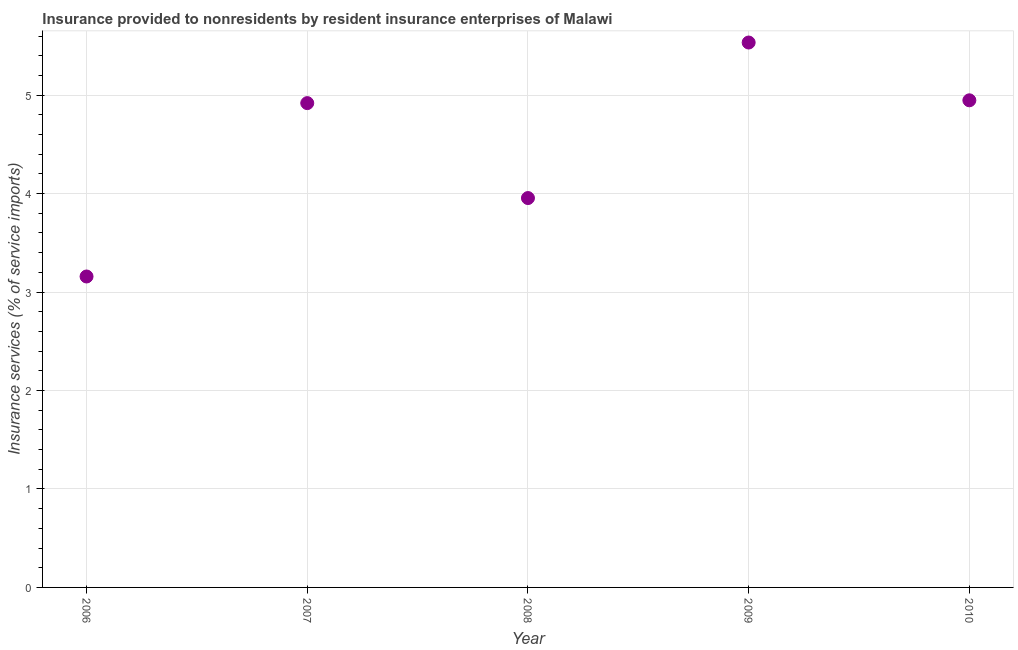What is the insurance and financial services in 2006?
Make the answer very short. 3.16. Across all years, what is the maximum insurance and financial services?
Keep it short and to the point. 5.53. Across all years, what is the minimum insurance and financial services?
Offer a very short reply. 3.16. In which year was the insurance and financial services maximum?
Provide a succinct answer. 2009. What is the sum of the insurance and financial services?
Provide a short and direct response. 22.51. What is the difference between the insurance and financial services in 2007 and 2010?
Provide a short and direct response. -0.03. What is the average insurance and financial services per year?
Your answer should be compact. 4.5. What is the median insurance and financial services?
Ensure brevity in your answer.  4.92. Do a majority of the years between 2009 and 2010 (inclusive) have insurance and financial services greater than 2.8 %?
Ensure brevity in your answer.  Yes. What is the ratio of the insurance and financial services in 2007 to that in 2010?
Your answer should be compact. 0.99. Is the insurance and financial services in 2008 less than that in 2009?
Offer a terse response. Yes. Is the difference between the insurance and financial services in 2008 and 2009 greater than the difference between any two years?
Offer a very short reply. No. What is the difference between the highest and the second highest insurance and financial services?
Provide a succinct answer. 0.59. What is the difference between the highest and the lowest insurance and financial services?
Make the answer very short. 2.38. In how many years, is the insurance and financial services greater than the average insurance and financial services taken over all years?
Ensure brevity in your answer.  3. How many dotlines are there?
Make the answer very short. 1. What is the difference between two consecutive major ticks on the Y-axis?
Provide a short and direct response. 1. What is the title of the graph?
Give a very brief answer. Insurance provided to nonresidents by resident insurance enterprises of Malawi. What is the label or title of the Y-axis?
Offer a very short reply. Insurance services (% of service imports). What is the Insurance services (% of service imports) in 2006?
Keep it short and to the point. 3.16. What is the Insurance services (% of service imports) in 2007?
Offer a terse response. 4.92. What is the Insurance services (% of service imports) in 2008?
Provide a short and direct response. 3.95. What is the Insurance services (% of service imports) in 2009?
Your answer should be compact. 5.53. What is the Insurance services (% of service imports) in 2010?
Your answer should be compact. 4.95. What is the difference between the Insurance services (% of service imports) in 2006 and 2007?
Provide a short and direct response. -1.76. What is the difference between the Insurance services (% of service imports) in 2006 and 2008?
Your answer should be compact. -0.8. What is the difference between the Insurance services (% of service imports) in 2006 and 2009?
Keep it short and to the point. -2.38. What is the difference between the Insurance services (% of service imports) in 2006 and 2010?
Keep it short and to the point. -1.79. What is the difference between the Insurance services (% of service imports) in 2007 and 2008?
Offer a very short reply. 0.96. What is the difference between the Insurance services (% of service imports) in 2007 and 2009?
Offer a terse response. -0.62. What is the difference between the Insurance services (% of service imports) in 2007 and 2010?
Your answer should be very brief. -0.03. What is the difference between the Insurance services (% of service imports) in 2008 and 2009?
Give a very brief answer. -1.58. What is the difference between the Insurance services (% of service imports) in 2008 and 2010?
Provide a succinct answer. -0.99. What is the difference between the Insurance services (% of service imports) in 2009 and 2010?
Provide a succinct answer. 0.59. What is the ratio of the Insurance services (% of service imports) in 2006 to that in 2007?
Your answer should be compact. 0.64. What is the ratio of the Insurance services (% of service imports) in 2006 to that in 2008?
Make the answer very short. 0.8. What is the ratio of the Insurance services (% of service imports) in 2006 to that in 2009?
Your answer should be compact. 0.57. What is the ratio of the Insurance services (% of service imports) in 2006 to that in 2010?
Keep it short and to the point. 0.64. What is the ratio of the Insurance services (% of service imports) in 2007 to that in 2008?
Offer a very short reply. 1.24. What is the ratio of the Insurance services (% of service imports) in 2007 to that in 2009?
Your answer should be very brief. 0.89. What is the ratio of the Insurance services (% of service imports) in 2007 to that in 2010?
Your answer should be compact. 0.99. What is the ratio of the Insurance services (% of service imports) in 2008 to that in 2009?
Your answer should be very brief. 0.71. What is the ratio of the Insurance services (% of service imports) in 2008 to that in 2010?
Your response must be concise. 0.8. What is the ratio of the Insurance services (% of service imports) in 2009 to that in 2010?
Your answer should be compact. 1.12. 